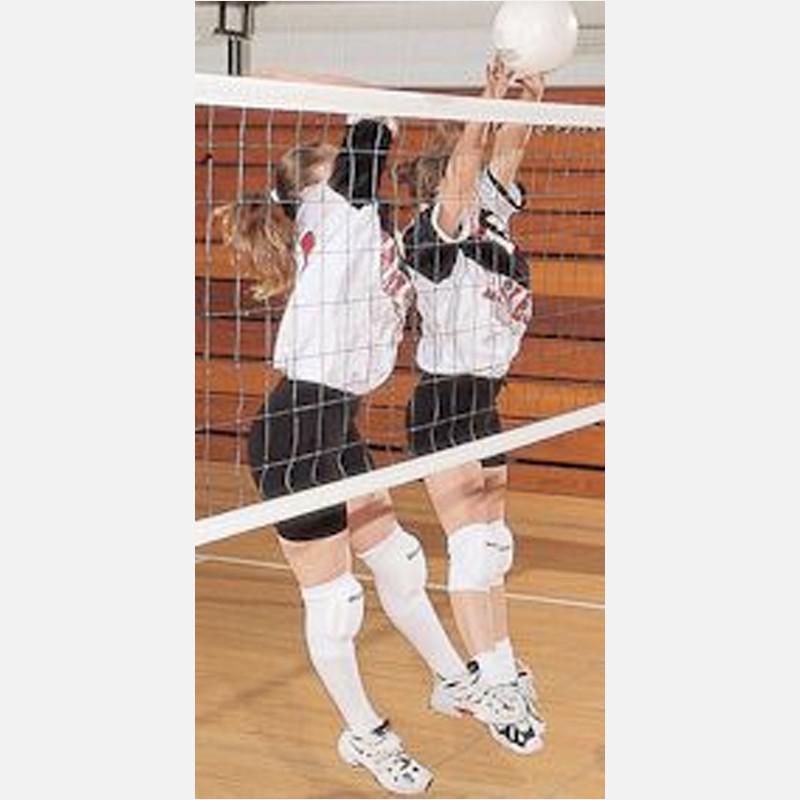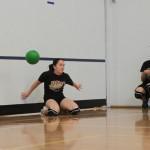The first image is the image on the left, the second image is the image on the right. For the images displayed, is the sentence "The left and right image contains a total of two women playing volleyball." factually correct? Answer yes or no. No. The first image is the image on the left, the second image is the image on the right. Given the left and right images, does the statement "One image features an upright girl reaching toward a volleyball with at least one foot off the ground, and the other image features a girl on at least one knee with a volleyball in front of one arm." hold true? Answer yes or no. Yes. 